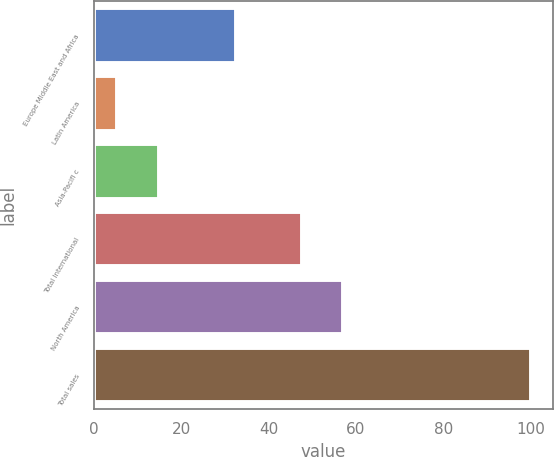Convert chart. <chart><loc_0><loc_0><loc_500><loc_500><bar_chart><fcel>Europe Middle East and Africa<fcel>Latin America<fcel>Asia-Pacifi c<fcel>Total International<fcel>North America<fcel>Total sales<nl><fcel>32.5<fcel>5.4<fcel>14.86<fcel>47.6<fcel>57.06<fcel>100<nl></chart> 